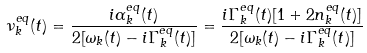<formula> <loc_0><loc_0><loc_500><loc_500>\nu _ { k } ^ { e q } ( t ) = \frac { i \alpha _ { k } ^ { e q } ( t ) } { 2 [ \omega _ { k } ( t ) - i \Gamma _ { k } ^ { e q } ( t ) ] } = \frac { i \Gamma _ { k } ^ { e q } ( t ) [ 1 + 2 n _ { k } ^ { e q } ( t ) ] } { 2 [ \omega _ { k } ( t ) - i \Gamma _ { k } ^ { e q } ( t ) ] }</formula> 